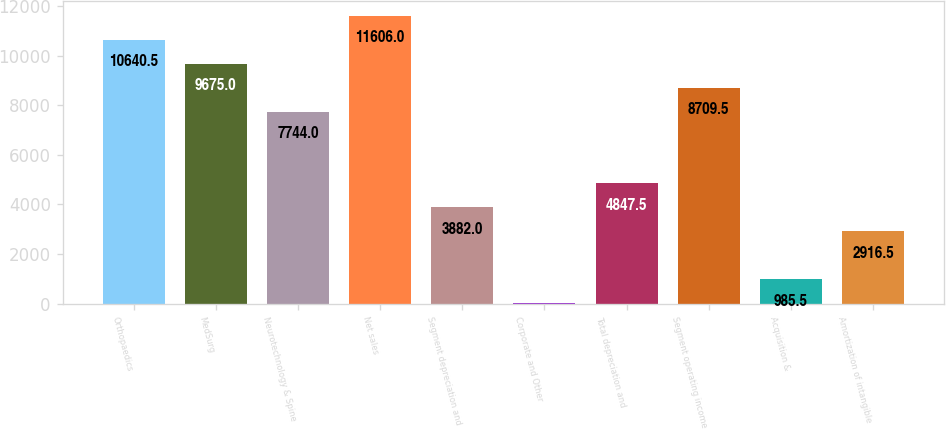Convert chart to OTSL. <chart><loc_0><loc_0><loc_500><loc_500><bar_chart><fcel>Orthopaedics<fcel>MedSurg<fcel>Neurotechnology & Spine<fcel>Net sales<fcel>Segment depreciation and<fcel>Corporate and Other<fcel>Total depreciation and<fcel>Segment operating income<fcel>Acquisition &<fcel>Amortization of intangible<nl><fcel>10640.5<fcel>9675<fcel>7744<fcel>11606<fcel>3882<fcel>20<fcel>4847.5<fcel>8709.5<fcel>985.5<fcel>2916.5<nl></chart> 